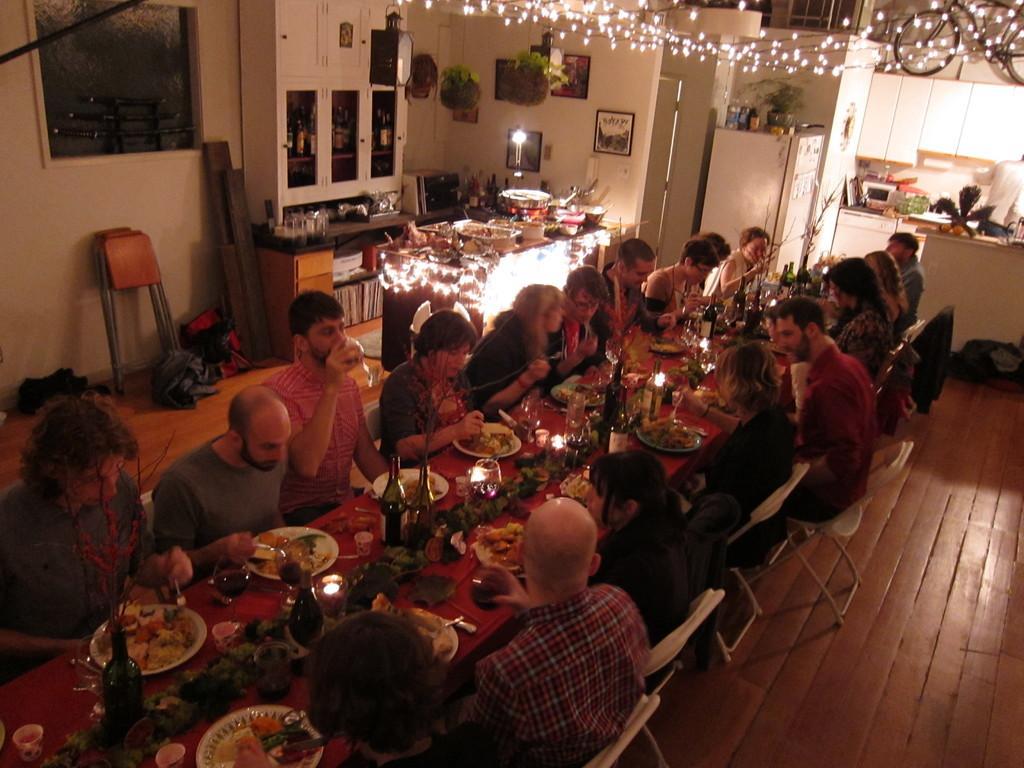Please provide a concise description of this image. In this, we can see a dining table. On top of the dining table, so many food items on the plate. Bottles, glasses. Peoples are sat on the chairs. We can see wooden floor. Here there is a table. On top of it, so many items are placed. Here we can see stools, white color wall. On top of the image, we can see lights and bicycle hire. Here we can see refrigerator, microwave oven, cupboards and things. Here we can see plants also, photo frames. 